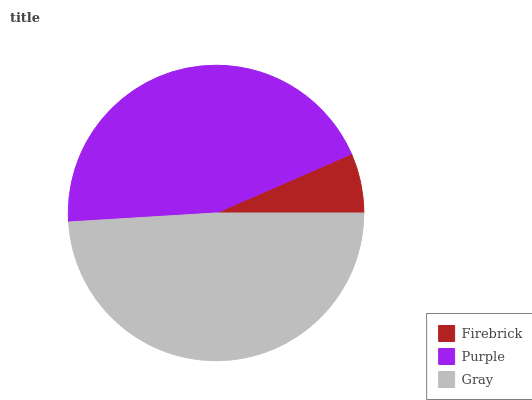Is Firebrick the minimum?
Answer yes or no. Yes. Is Gray the maximum?
Answer yes or no. Yes. Is Purple the minimum?
Answer yes or no. No. Is Purple the maximum?
Answer yes or no. No. Is Purple greater than Firebrick?
Answer yes or no. Yes. Is Firebrick less than Purple?
Answer yes or no. Yes. Is Firebrick greater than Purple?
Answer yes or no. No. Is Purple less than Firebrick?
Answer yes or no. No. Is Purple the high median?
Answer yes or no. Yes. Is Purple the low median?
Answer yes or no. Yes. Is Firebrick the high median?
Answer yes or no. No. Is Firebrick the low median?
Answer yes or no. No. 